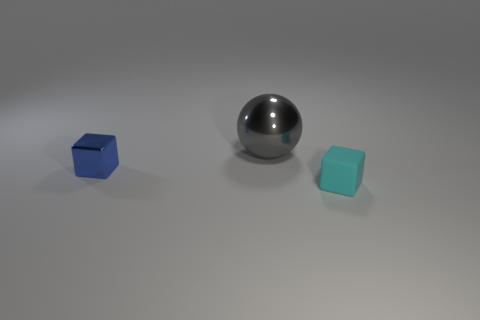Add 1 tiny cyan matte blocks. How many objects exist? 4 Subtract all cubes. How many objects are left? 1 Subtract 0 cyan cylinders. How many objects are left? 3 Subtract all tiny blue things. Subtract all big red cubes. How many objects are left? 2 Add 3 balls. How many balls are left? 4 Add 3 gray objects. How many gray objects exist? 4 